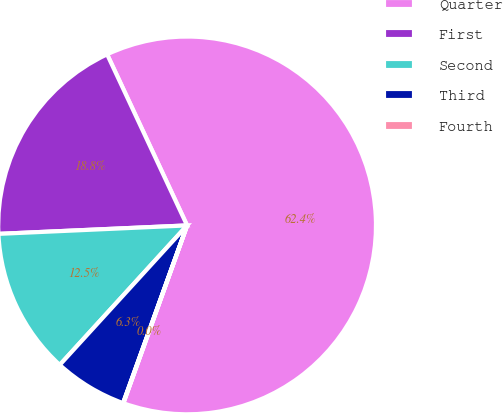<chart> <loc_0><loc_0><loc_500><loc_500><pie_chart><fcel>Quarter<fcel>First<fcel>Second<fcel>Third<fcel>Fourth<nl><fcel>62.43%<fcel>18.75%<fcel>12.51%<fcel>6.27%<fcel>0.03%<nl></chart> 